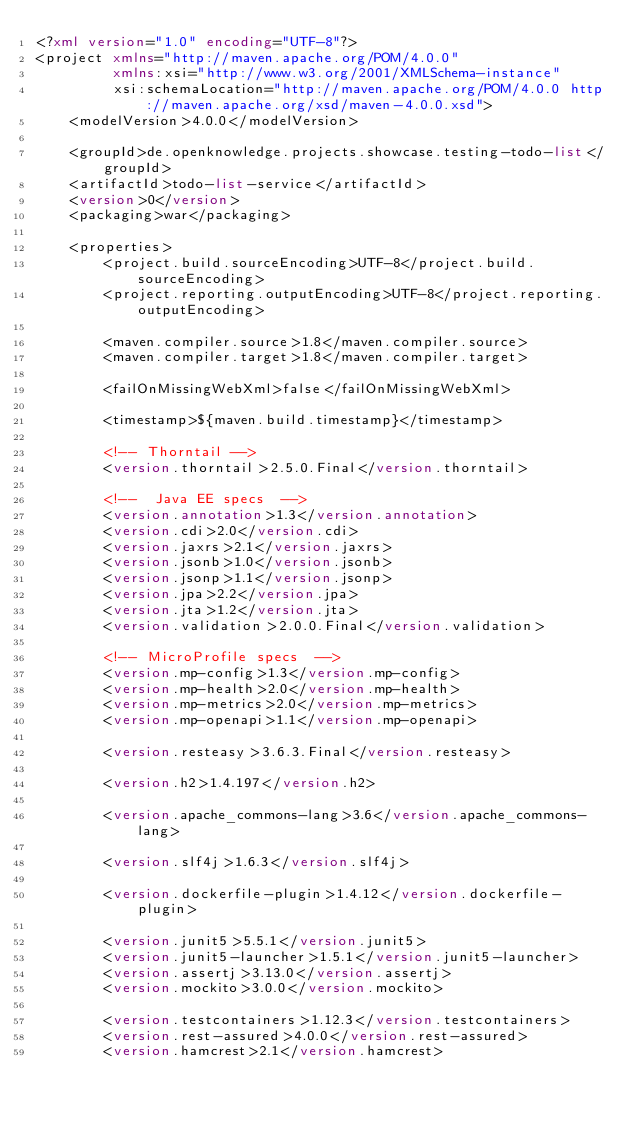Convert code to text. <code><loc_0><loc_0><loc_500><loc_500><_XML_><?xml version="1.0" encoding="UTF-8"?>
<project xmlns="http://maven.apache.org/POM/4.0.0"
         xmlns:xsi="http://www.w3.org/2001/XMLSchema-instance"
         xsi:schemaLocation="http://maven.apache.org/POM/4.0.0 http://maven.apache.org/xsd/maven-4.0.0.xsd">
    <modelVersion>4.0.0</modelVersion>

    <groupId>de.openknowledge.projects.showcase.testing-todo-list</groupId>
    <artifactId>todo-list-service</artifactId>
    <version>0</version>
    <packaging>war</packaging>

    <properties>
        <project.build.sourceEncoding>UTF-8</project.build.sourceEncoding>
        <project.reporting.outputEncoding>UTF-8</project.reporting.outputEncoding>

        <maven.compiler.source>1.8</maven.compiler.source>
        <maven.compiler.target>1.8</maven.compiler.target>

        <failOnMissingWebXml>false</failOnMissingWebXml>

        <timestamp>${maven.build.timestamp}</timestamp>

        <!-- Thorntail -->
        <version.thorntail>2.5.0.Final</version.thorntail>

        <!--  Java EE specs  -->
        <version.annotation>1.3</version.annotation>
        <version.cdi>2.0</version.cdi>
        <version.jaxrs>2.1</version.jaxrs>
        <version.jsonb>1.0</version.jsonb>
        <version.jsonp>1.1</version.jsonp>
        <version.jpa>2.2</version.jpa>
        <version.jta>1.2</version.jta>
        <version.validation>2.0.0.Final</version.validation>

        <!-- MicroProfile specs  -->
        <version.mp-config>1.3</version.mp-config>
        <version.mp-health>2.0</version.mp-health>
        <version.mp-metrics>2.0</version.mp-metrics>
        <version.mp-openapi>1.1</version.mp-openapi>

        <version.resteasy>3.6.3.Final</version.resteasy>

        <version.h2>1.4.197</version.h2>

        <version.apache_commons-lang>3.6</version.apache_commons-lang>

        <version.slf4j>1.6.3</version.slf4j>

        <version.dockerfile-plugin>1.4.12</version.dockerfile-plugin>

        <version.junit5>5.5.1</version.junit5>
        <version.junit5-launcher>1.5.1</version.junit5-launcher>
        <version.assertj>3.13.0</version.assertj>
        <version.mockito>3.0.0</version.mockito>

        <version.testcontainers>1.12.3</version.testcontainers>
        <version.rest-assured>4.0.0</version.rest-assured>
        <version.hamcrest>2.1</version.hamcrest>
</code> 